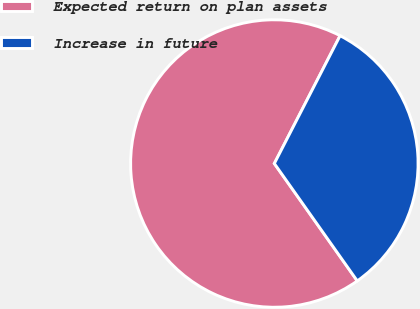Convert chart. <chart><loc_0><loc_0><loc_500><loc_500><pie_chart><fcel>Expected return on plan assets<fcel>Increase in future<nl><fcel>67.35%<fcel>32.65%<nl></chart> 